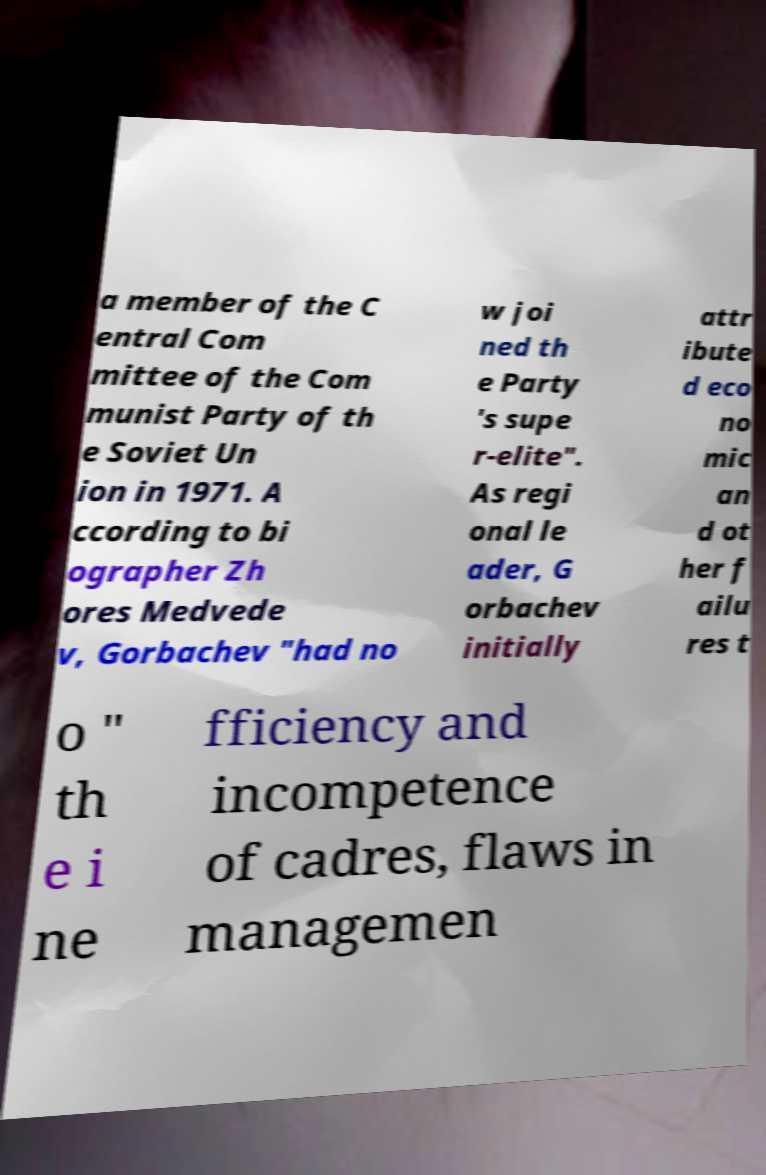There's text embedded in this image that I need extracted. Can you transcribe it verbatim? a member of the C entral Com mittee of the Com munist Party of th e Soviet Un ion in 1971. A ccording to bi ographer Zh ores Medvede v, Gorbachev "had no w joi ned th e Party 's supe r-elite". As regi onal le ader, G orbachev initially attr ibute d eco no mic an d ot her f ailu res t o " th e i ne fficiency and incompetence of cadres, flaws in managemen 